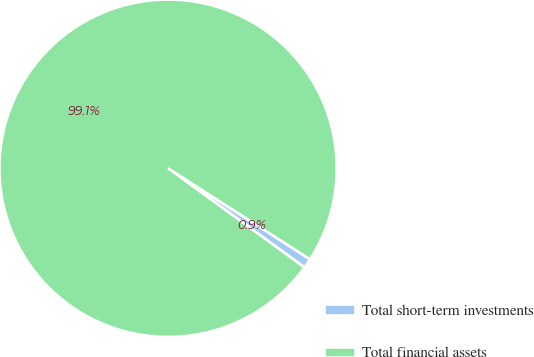Convert chart. <chart><loc_0><loc_0><loc_500><loc_500><pie_chart><fcel>Total short-term investments<fcel>Total financial assets<nl><fcel>0.93%<fcel>99.07%<nl></chart> 